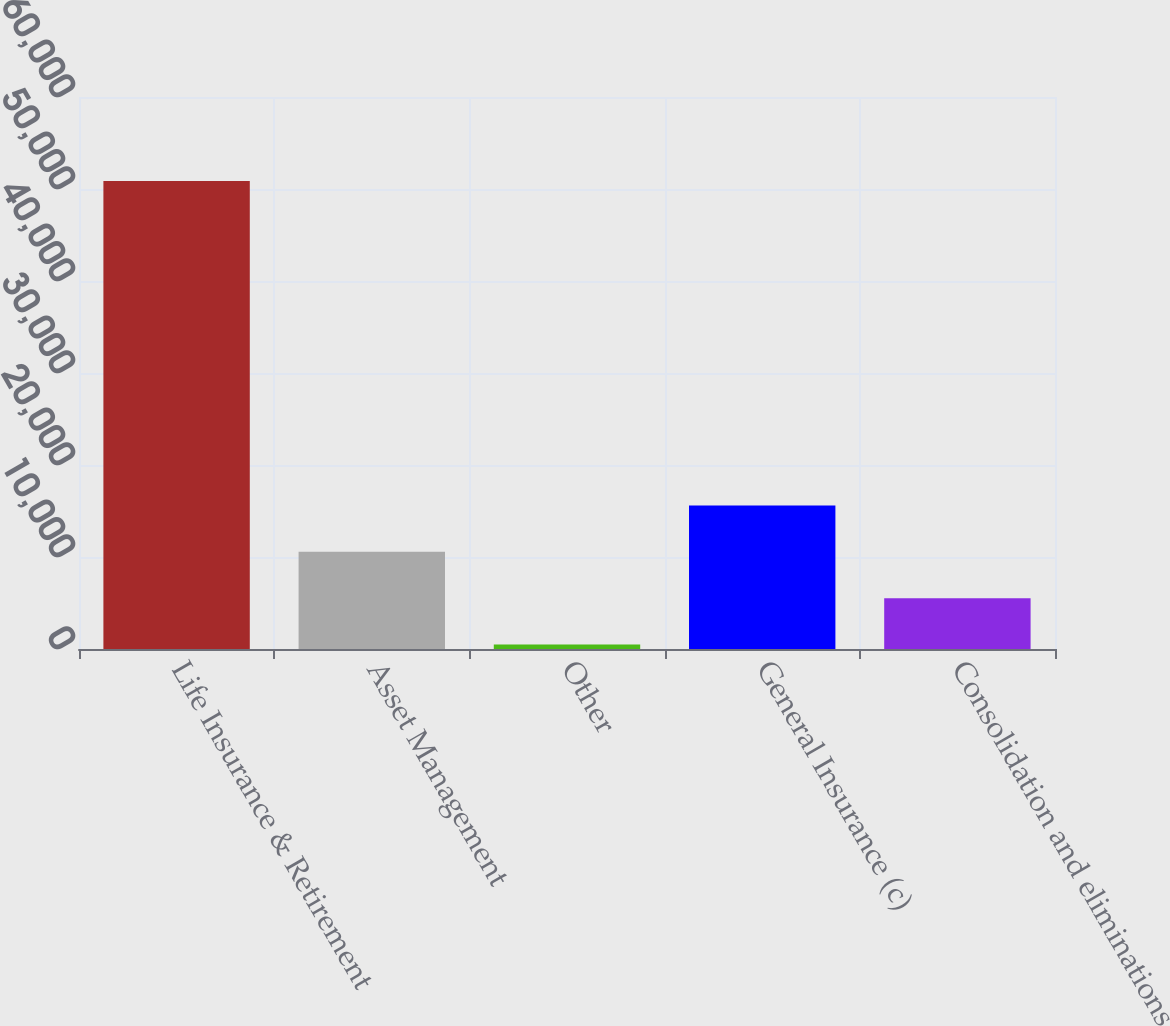Convert chart to OTSL. <chart><loc_0><loc_0><loc_500><loc_500><bar_chart><fcel>Life Insurance & Retirement<fcel>Asset Management<fcel>Other<fcel>General Insurance (c)<fcel>Consolidation and eliminations<nl><fcel>50878<fcel>10562<fcel>483<fcel>15601.5<fcel>5522.5<nl></chart> 